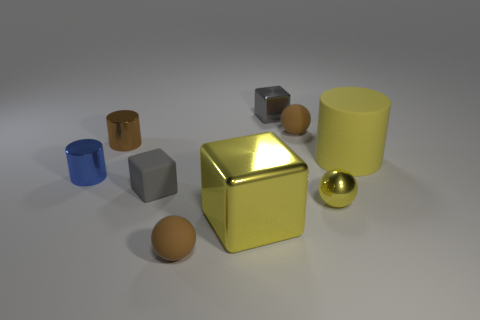Subtract 1 spheres. How many spheres are left? 2 Subtract all small cubes. How many cubes are left? 1 Subtract all spheres. How many objects are left? 6 Add 1 brown matte balls. How many objects exist? 10 Subtract all brown balls. How many balls are left? 1 Subtract 1 gray blocks. How many objects are left? 8 Subtract all green balls. Subtract all brown cubes. How many balls are left? 3 Subtract all purple blocks. How many gray cylinders are left? 0 Subtract all small cubes. Subtract all yellow metallic things. How many objects are left? 5 Add 1 gray metallic objects. How many gray metallic objects are left? 2 